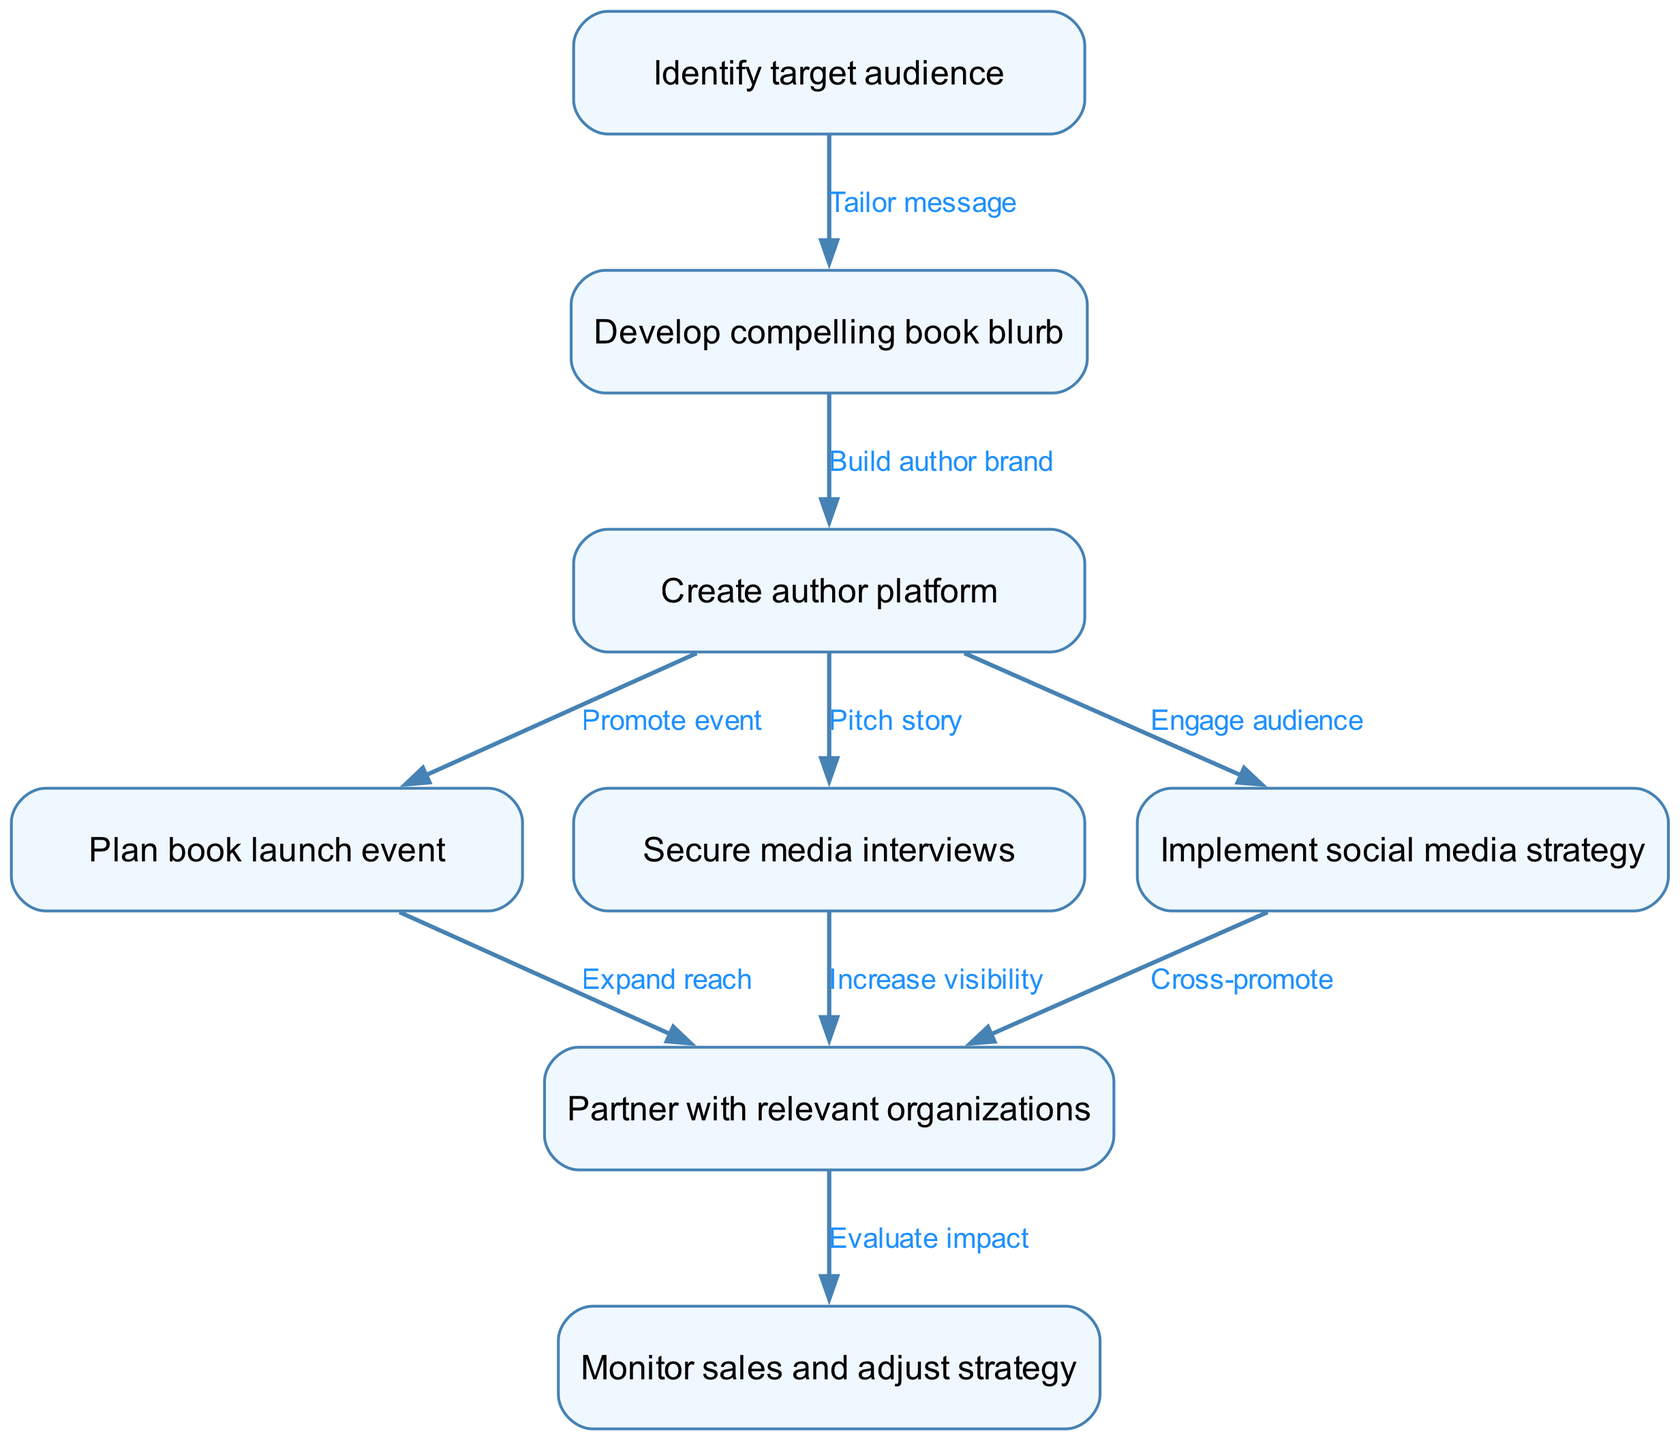What is the first step in the marketing campaign strategy? The diagram starts with the node labeled "Identify target audience," which is indicated as the first step in the flow.
Answer: Identify target audience How many nodes are in the flow chart? To find the total number of nodes, we count each distinct node listed, which gives us eight nodes in total.
Answer: 8 What is the relationship between "Create author platform" and "Plan book launch event"? The diagram indicates a direct relationship where "Create author platform" leads to "Plan book launch event," showing that building an author platform is necessary for planning the event.
Answer: Promote event Which node leads to "Monitor sales and adjust strategy"? The node "Partner with relevant organizations" directly leads to "Monitor sales and adjust strategy," establishing a connection where partnerships contribute to evaluating the impact of the campaign.
Answer: Partner with relevant organizations How many edges connect to "Secure media interviews"? By examining the diagram, we see that "Secure media interviews" connects to only one edge leading to "Partner with relevant organizations," meaning it has one outgoing connection.
Answer: 1 What effect does "Implement social media strategy" have on "Partner with relevant organizations"? The diagram shows that "Implement social media strategy" connects directly to "Partner with relevant organizations" with the phrasing "Cross-promote," indicating that social media efforts enhance partnerships.
Answer: Cross-promote What is the last step in the marketing campaign strategy? The final step of the flow chart is labeled "Monitor sales and adjust strategy," showing it as the concluding action of the marketing campaign process.
Answer: Monitor sales and adjust strategy Which two nodes are directly connected to "Plan book launch event"? "Create author platform" connects to "Plan book launch event," and "Partner with relevant organizations" is the other node connected to it, indicating that both aspects influence the launch planning.
Answer: Create author platform and Partner with relevant organizations What is the purpose of identifying the target audience? The node "Identify target audience" leads to "Develop compelling book blurb," implying that understanding the audience is critical for crafting a message that resonates.
Answer: Tailor message 